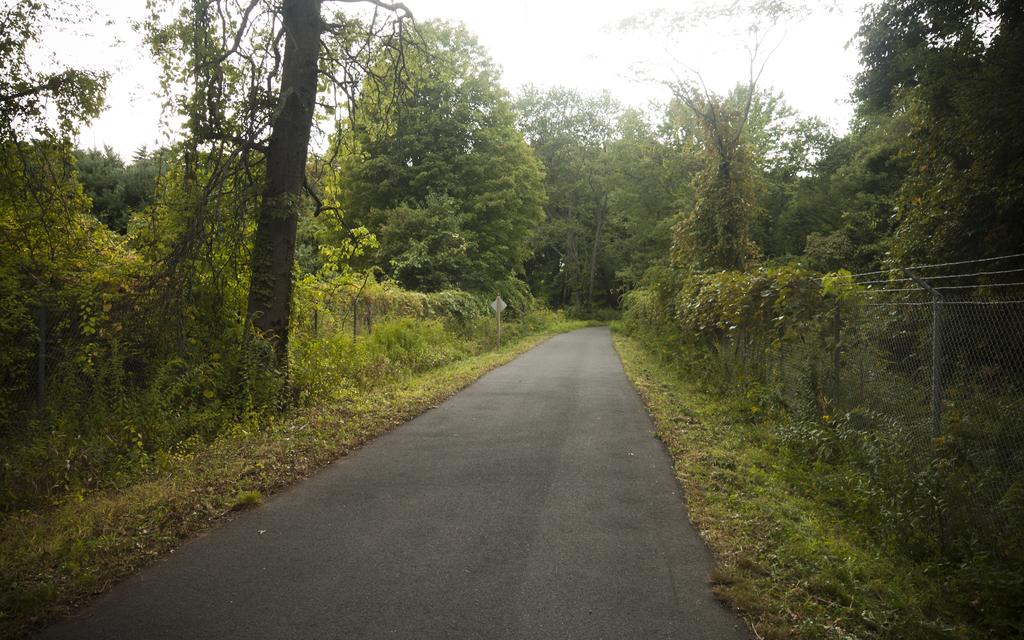What type of setting is depicted in the image? The image has an outside view. What can be seen on the ground in the image? There is a road in the image. What type of vegetation is present in the image? Trees are present in the image. What is on the right side of the image? There is a fencing on the right side of the image. What is visible at the top of the image? The sky is visible at the top of the image. What type of skirt is being worn by the destruction in the image? There is no destruction or skirt present in the image. What type of vacation is being taken by the trees in the image? There is no vacation or indication of a vacation in the image; it simply shows trees and other elements of the outdoor setting. 